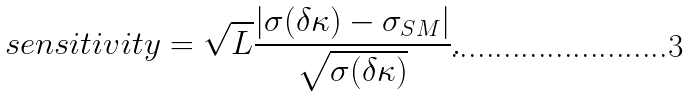<formula> <loc_0><loc_0><loc_500><loc_500>s e n s i t i v i t y = \sqrt { L } \frac { \left | \sigma ( \delta \kappa ) - \sigma _ { S M } \right | } { \sqrt { \sigma ( \delta \kappa ) } } .</formula> 